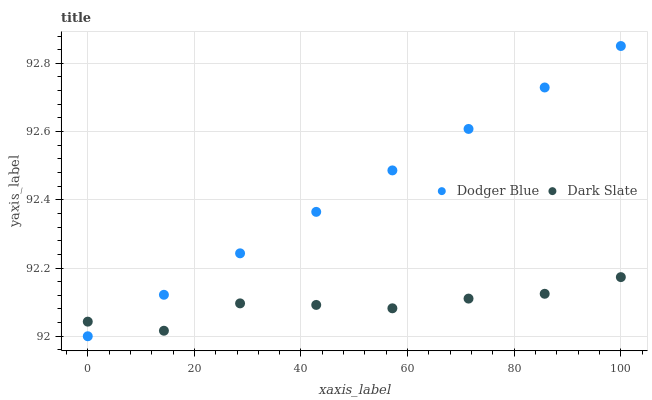Does Dark Slate have the minimum area under the curve?
Answer yes or no. Yes. Does Dodger Blue have the maximum area under the curve?
Answer yes or no. Yes. Does Dodger Blue have the minimum area under the curve?
Answer yes or no. No. Is Dodger Blue the smoothest?
Answer yes or no. Yes. Is Dark Slate the roughest?
Answer yes or no. Yes. Is Dodger Blue the roughest?
Answer yes or no. No. Does Dodger Blue have the lowest value?
Answer yes or no. Yes. Does Dodger Blue have the highest value?
Answer yes or no. Yes. Does Dodger Blue intersect Dark Slate?
Answer yes or no. Yes. Is Dodger Blue less than Dark Slate?
Answer yes or no. No. Is Dodger Blue greater than Dark Slate?
Answer yes or no. No. 